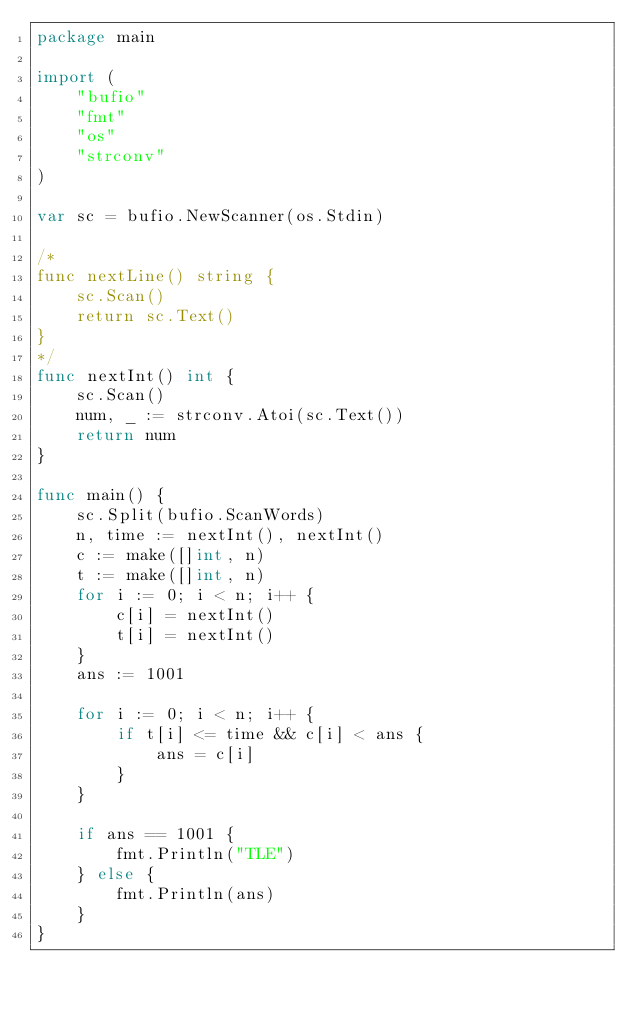Convert code to text. <code><loc_0><loc_0><loc_500><loc_500><_Go_>package main

import (
	"bufio"
	"fmt"
	"os"
	"strconv"
)

var sc = bufio.NewScanner(os.Stdin)

/*
func nextLine() string {
	sc.Scan()
	return sc.Text()
}
*/
func nextInt() int {
	sc.Scan()
	num, _ := strconv.Atoi(sc.Text())
	return num
}

func main() {
	sc.Split(bufio.ScanWords)
	n, time := nextInt(), nextInt()
	c := make([]int, n)
	t := make([]int, n)
	for i := 0; i < n; i++ {
		c[i] = nextInt()
		t[i] = nextInt()
	}
	ans := 1001

	for i := 0; i < n; i++ {
		if t[i] <= time && c[i] < ans {
			ans = c[i]
		}
	}

	if ans == 1001 {
		fmt.Println("TLE")
	} else {
		fmt.Println(ans)
	}
}
</code> 